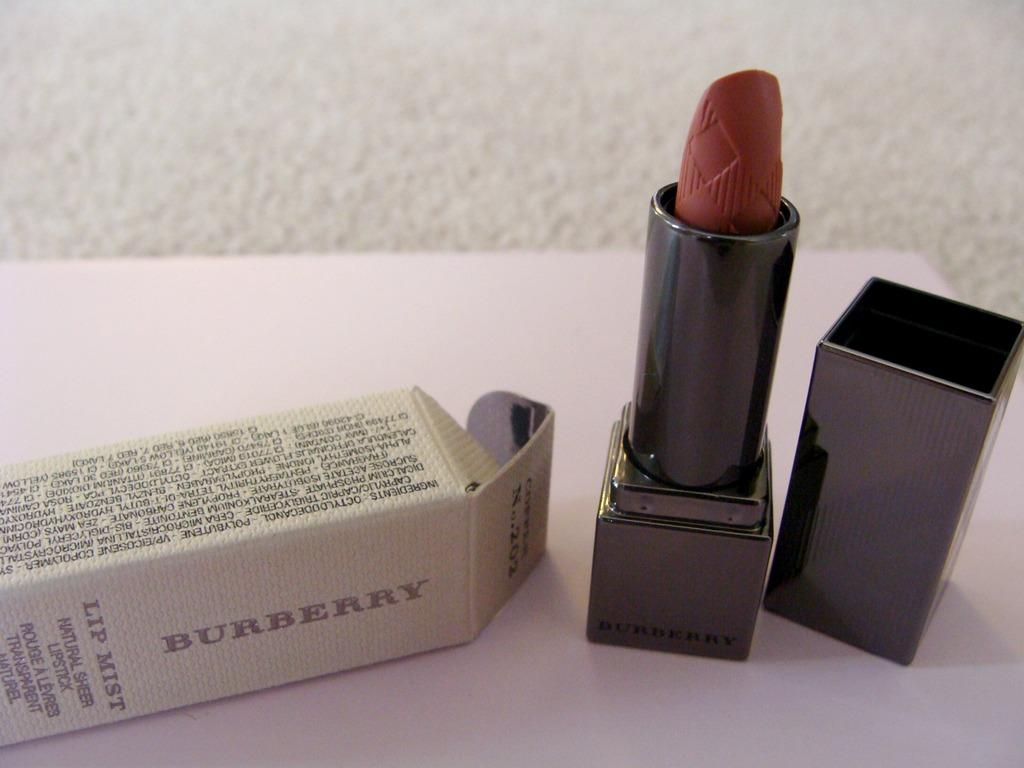What is one of the objects in the image? There is a box in the image. What is another object in the image? There is lipstick in the image. What is the third object in the image? There is a cap in the image. What is the color of the surface on which the objects are placed? The objects are on a white color surface. How many engines are visible in the image? There are no engines present in the image. What type of humor can be found in the image? There is no humor depicted in the image; it simply shows a box, lipstick, and a cap on a white surface. 